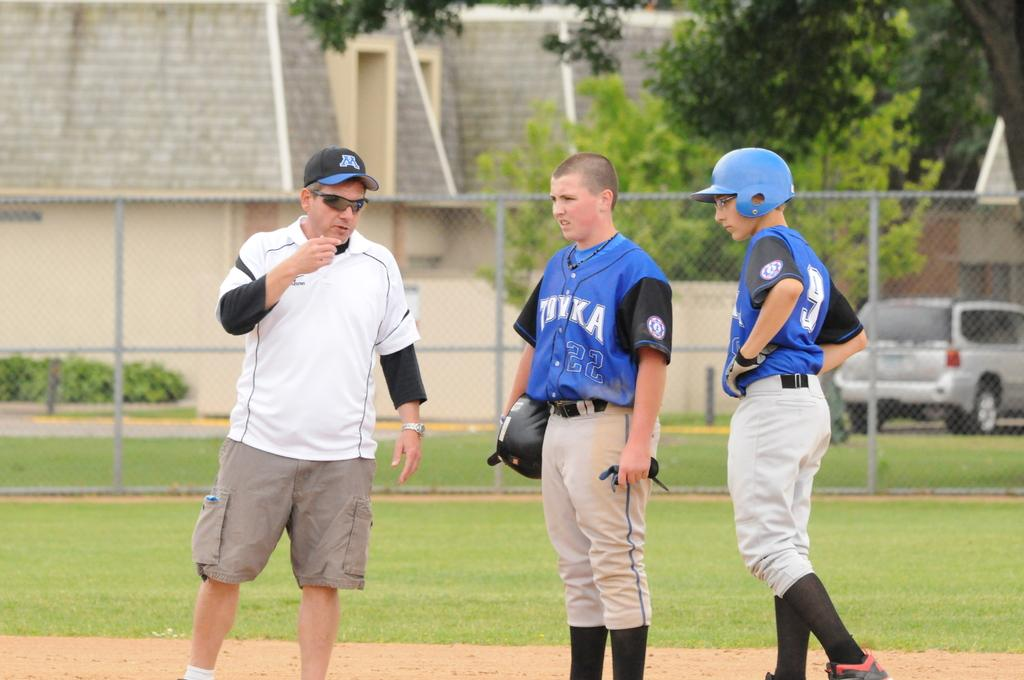<image>
Render a clear and concise summary of the photo. A young ball player in a number 9 shirt stands with his team mate and a man wearing a cap with an W on it. 